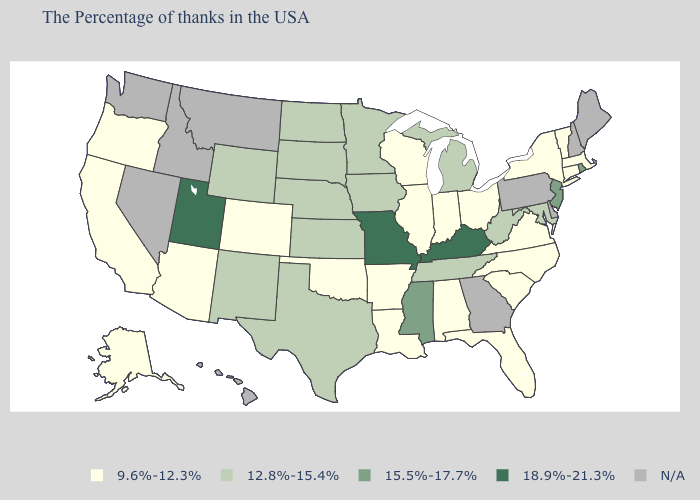What is the lowest value in the USA?
Concise answer only. 9.6%-12.3%. Name the states that have a value in the range 15.5%-17.7%?
Give a very brief answer. Rhode Island, New Jersey, Mississippi. What is the lowest value in the USA?
Concise answer only. 9.6%-12.3%. What is the lowest value in the USA?
Concise answer only. 9.6%-12.3%. Name the states that have a value in the range 12.8%-15.4%?
Write a very short answer. Maryland, West Virginia, Michigan, Tennessee, Minnesota, Iowa, Kansas, Nebraska, Texas, South Dakota, North Dakota, Wyoming, New Mexico. Name the states that have a value in the range N/A?
Keep it brief. Maine, New Hampshire, Delaware, Pennsylvania, Georgia, Montana, Idaho, Nevada, Washington, Hawaii. What is the highest value in the USA?
Be succinct. 18.9%-21.3%. What is the highest value in the South ?
Quick response, please. 18.9%-21.3%. Among the states that border Tennessee , does Arkansas have the highest value?
Short answer required. No. Which states have the lowest value in the USA?
Write a very short answer. Massachusetts, Vermont, Connecticut, New York, Virginia, North Carolina, South Carolina, Ohio, Florida, Indiana, Alabama, Wisconsin, Illinois, Louisiana, Arkansas, Oklahoma, Colorado, Arizona, California, Oregon, Alaska. What is the value of Kentucky?
Keep it brief. 18.9%-21.3%. Name the states that have a value in the range 9.6%-12.3%?
Be succinct. Massachusetts, Vermont, Connecticut, New York, Virginia, North Carolina, South Carolina, Ohio, Florida, Indiana, Alabama, Wisconsin, Illinois, Louisiana, Arkansas, Oklahoma, Colorado, Arizona, California, Oregon, Alaska. Is the legend a continuous bar?
Write a very short answer. No. What is the value of Idaho?
Short answer required. N/A. Which states have the lowest value in the Northeast?
Keep it brief. Massachusetts, Vermont, Connecticut, New York. 